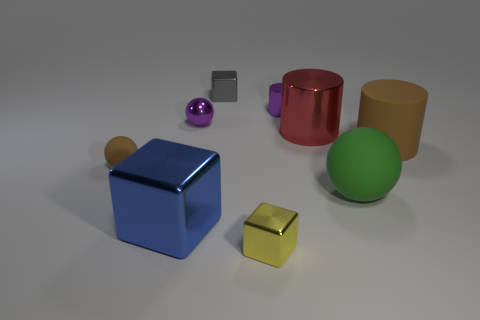Are there any big green balls on the left side of the tiny cylinder?
Offer a terse response. No. What material is the large object that is the same color as the tiny matte sphere?
Your answer should be compact. Rubber. Are the brown object on the left side of the big brown object and the green object made of the same material?
Offer a terse response. Yes. Is there a brown cylinder that is behind the red thing that is behind the matte ball that is behind the large green ball?
Provide a short and direct response. No. How many cylinders are either red metal objects or brown matte things?
Provide a short and direct response. 2. There is a tiny sphere that is behind the big matte cylinder; what material is it?
Make the answer very short. Metal. There is a ball that is the same color as the small cylinder; what size is it?
Offer a terse response. Small. There is a object right of the large green matte ball; is its color the same as the small thing right of the small yellow thing?
Provide a succinct answer. No. How many things are either big yellow metal things or big shiny things?
Your response must be concise. 2. How many other things are there of the same shape as the blue object?
Your response must be concise. 2. 